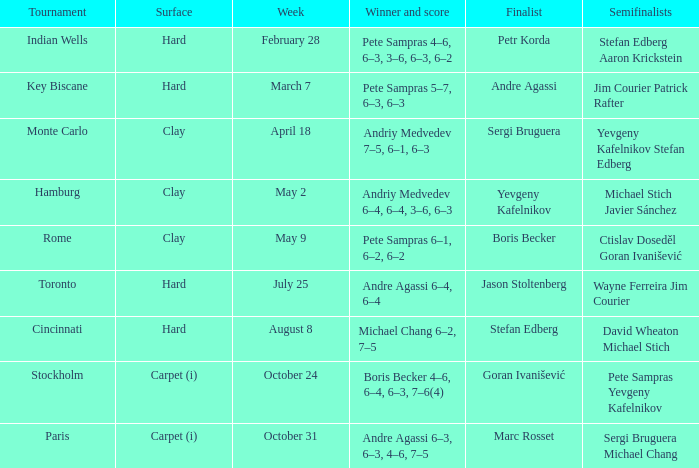Who was the semifinalist for the key biscane tournament? Jim Courier Patrick Rafter. 